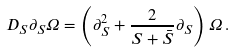Convert formula to latex. <formula><loc_0><loc_0><loc_500><loc_500>D _ { S } \partial _ { S } \Omega = \left ( \partial _ { S } ^ { 2 } + \frac { 2 } { S + \bar { S } } \partial _ { S } \right ) \Omega \, .</formula> 